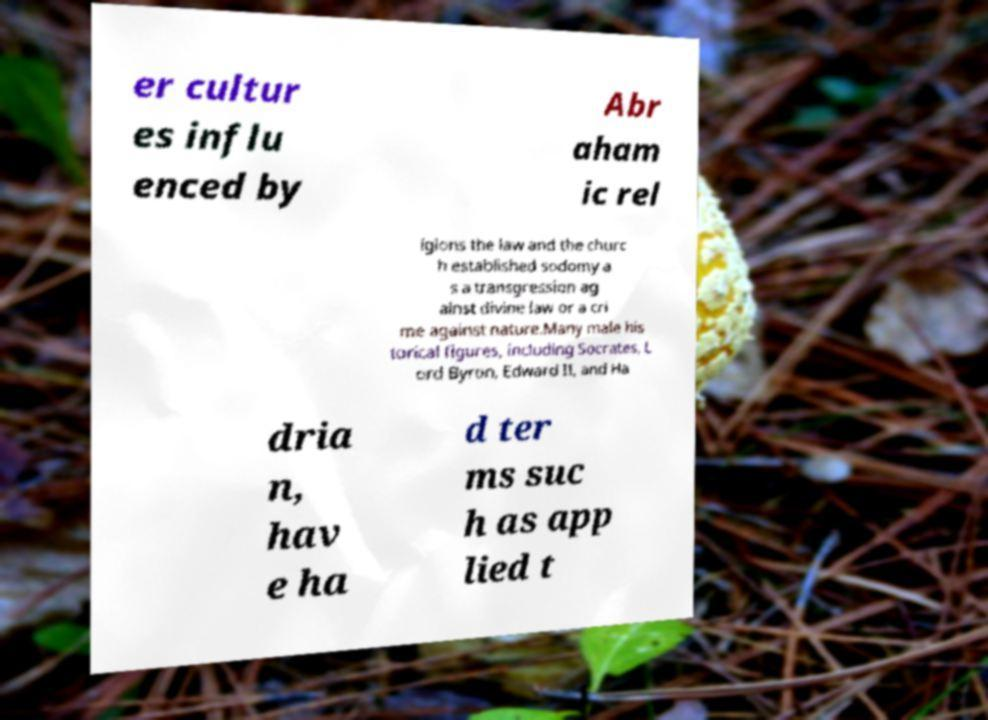There's text embedded in this image that I need extracted. Can you transcribe it verbatim? er cultur es influ enced by Abr aham ic rel igions the law and the churc h established sodomy a s a transgression ag ainst divine law or a cri me against nature.Many male his torical figures, including Socrates, L ord Byron, Edward II, and Ha dria n, hav e ha d ter ms suc h as app lied t 